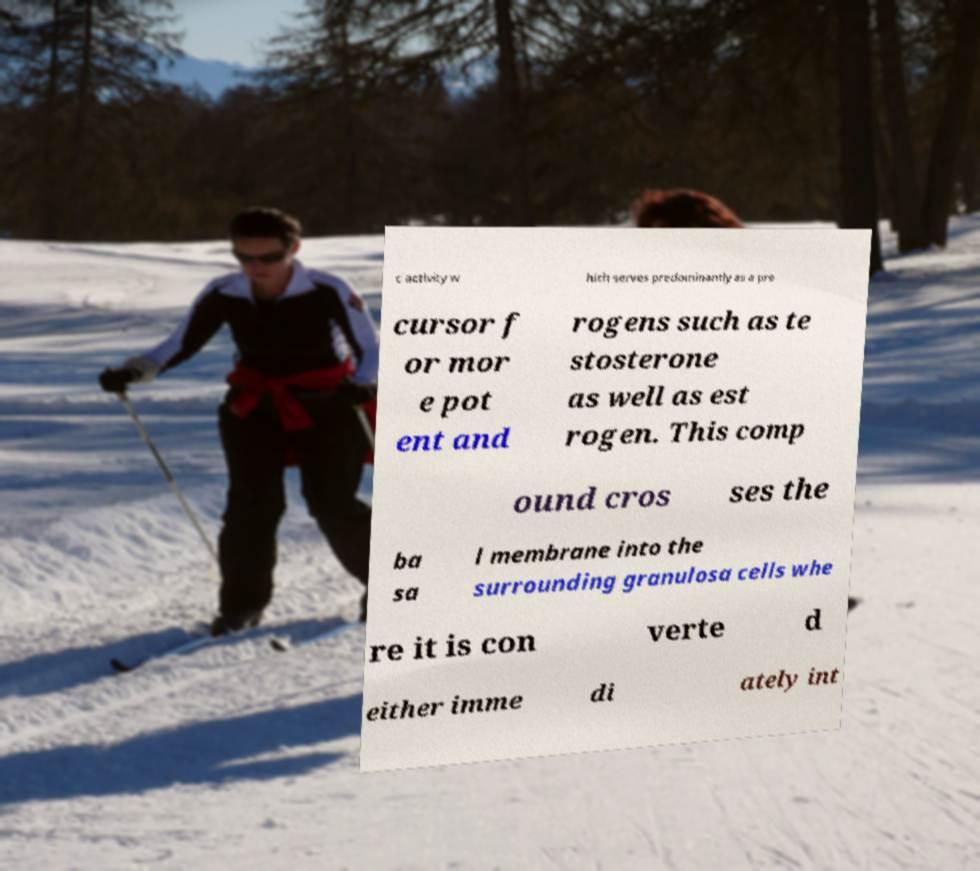What messages or text are displayed in this image? I need them in a readable, typed format. c activity w hich serves predominantly as a pre cursor f or mor e pot ent and rogens such as te stosterone as well as est rogen. This comp ound cros ses the ba sa l membrane into the surrounding granulosa cells whe re it is con verte d either imme di ately int 